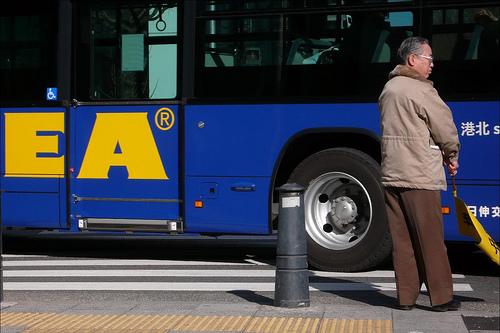Is the person wearing boots?
Keep it brief. No. What color is the bus?
Short answer required. Blue. Does the bike rider's shirt match the bus?
Be succinct. No. Is the man trying to enter the bus?
Be succinct. No. Is the bus equipped for handicapped passengers?
Write a very short answer. Yes. 